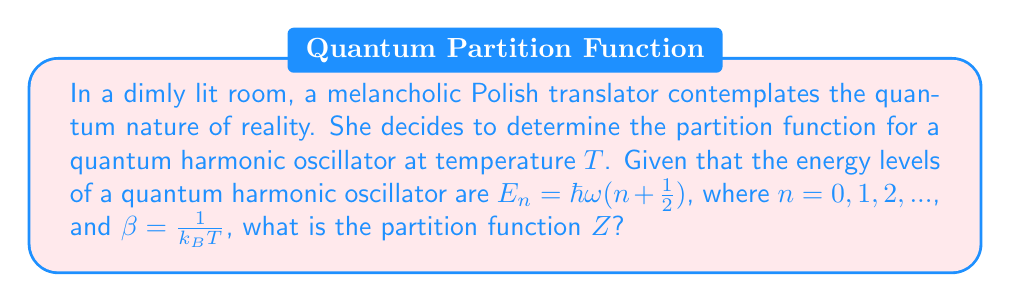Show me your answer to this math problem. Let's approach this step-by-step:

1) The partition function $Z$ is defined as the sum over all possible states:

   $$Z = \sum_{n=0}^{\infty} e^{-\beta E_n}$$

2) Substituting the energy levels:

   $$Z = \sum_{n=0}^{\infty} e^{-\beta \hbar\omega(n + \frac{1}{2})}$$

3) This can be rewritten as:

   $$Z = e^{-\beta \hbar\omega/2} \sum_{n=0}^{\infty} (e^{-\beta \hbar\omega})^n$$

4) Recognize that this is a geometric series with first term $a=1$ and common ratio $r=e^{-\beta \hbar\omega}$:

   $$Z = e^{-\beta \hbar\omega/2} \cdot \frac{1}{1-e^{-\beta \hbar\omega}}$$

5) Simplify:

   $$Z = \frac{e^{-\beta \hbar\omega/2}}{1-e^{-\beta \hbar\omega}}$$

6) This can be further simplified by multiplying numerator and denominator by $e^{\beta \hbar\omega/2}$:

   $$Z = \frac{1}{e^{\beta \hbar\omega/2} - e^{-\beta \hbar\omega/2}}$$

7) Recognize the hyperbolic sine function:

   $$Z = \frac{1}{2 \sinh(\beta \hbar\omega/2)}$$
Answer: $Z = \frac{1}{2 \sinh(\beta \hbar\omega/2)}$ 